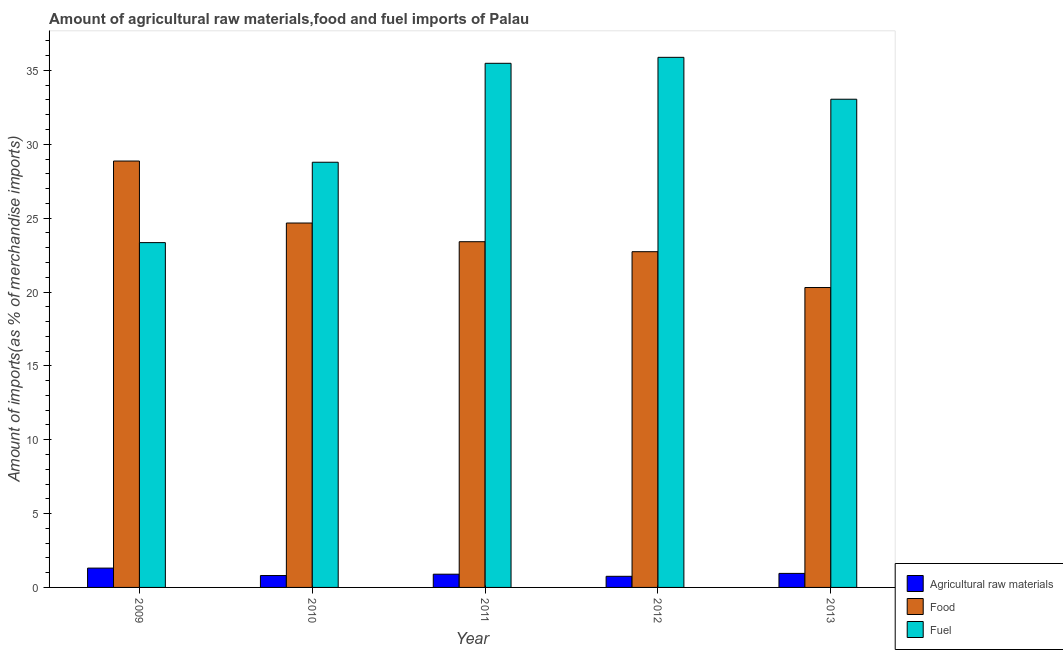Are the number of bars on each tick of the X-axis equal?
Ensure brevity in your answer.  Yes. What is the percentage of fuel imports in 2009?
Offer a very short reply. 23.34. Across all years, what is the maximum percentage of fuel imports?
Keep it short and to the point. 35.89. Across all years, what is the minimum percentage of food imports?
Ensure brevity in your answer.  20.3. What is the total percentage of fuel imports in the graph?
Your answer should be very brief. 156.55. What is the difference between the percentage of food imports in 2011 and that in 2012?
Provide a short and direct response. 0.68. What is the difference between the percentage of raw materials imports in 2010 and the percentage of fuel imports in 2011?
Ensure brevity in your answer.  -0.09. What is the average percentage of food imports per year?
Your response must be concise. 23.99. In the year 2010, what is the difference between the percentage of raw materials imports and percentage of fuel imports?
Provide a succinct answer. 0. What is the ratio of the percentage of raw materials imports in 2012 to that in 2013?
Make the answer very short. 0.79. Is the percentage of food imports in 2012 less than that in 2013?
Offer a terse response. No. Is the difference between the percentage of fuel imports in 2009 and 2010 greater than the difference between the percentage of food imports in 2009 and 2010?
Keep it short and to the point. No. What is the difference between the highest and the second highest percentage of raw materials imports?
Provide a succinct answer. 0.36. What is the difference between the highest and the lowest percentage of raw materials imports?
Your answer should be compact. 0.55. In how many years, is the percentage of food imports greater than the average percentage of food imports taken over all years?
Offer a terse response. 2. Is the sum of the percentage of raw materials imports in 2012 and 2013 greater than the maximum percentage of food imports across all years?
Ensure brevity in your answer.  Yes. What does the 3rd bar from the left in 2012 represents?
Make the answer very short. Fuel. What does the 3rd bar from the right in 2009 represents?
Keep it short and to the point. Agricultural raw materials. Is it the case that in every year, the sum of the percentage of raw materials imports and percentage of food imports is greater than the percentage of fuel imports?
Your response must be concise. No. How many bars are there?
Your response must be concise. 15. Are all the bars in the graph horizontal?
Your response must be concise. No. Does the graph contain any zero values?
Make the answer very short. No. Does the graph contain grids?
Give a very brief answer. No. Where does the legend appear in the graph?
Your response must be concise. Bottom right. What is the title of the graph?
Ensure brevity in your answer.  Amount of agricultural raw materials,food and fuel imports of Palau. What is the label or title of the Y-axis?
Your answer should be compact. Amount of imports(as % of merchandise imports). What is the Amount of imports(as % of merchandise imports) in Agricultural raw materials in 2009?
Your response must be concise. 1.31. What is the Amount of imports(as % of merchandise imports) of Food in 2009?
Ensure brevity in your answer.  28.87. What is the Amount of imports(as % of merchandise imports) of Fuel in 2009?
Provide a succinct answer. 23.34. What is the Amount of imports(as % of merchandise imports) of Agricultural raw materials in 2010?
Keep it short and to the point. 0.8. What is the Amount of imports(as % of merchandise imports) of Food in 2010?
Your response must be concise. 24.67. What is the Amount of imports(as % of merchandise imports) in Fuel in 2010?
Provide a succinct answer. 28.78. What is the Amount of imports(as % of merchandise imports) in Agricultural raw materials in 2011?
Offer a terse response. 0.9. What is the Amount of imports(as % of merchandise imports) in Food in 2011?
Your response must be concise. 23.4. What is the Amount of imports(as % of merchandise imports) of Fuel in 2011?
Make the answer very short. 35.48. What is the Amount of imports(as % of merchandise imports) of Agricultural raw materials in 2012?
Provide a succinct answer. 0.75. What is the Amount of imports(as % of merchandise imports) in Food in 2012?
Ensure brevity in your answer.  22.73. What is the Amount of imports(as % of merchandise imports) in Fuel in 2012?
Offer a terse response. 35.89. What is the Amount of imports(as % of merchandise imports) in Agricultural raw materials in 2013?
Provide a short and direct response. 0.95. What is the Amount of imports(as % of merchandise imports) of Food in 2013?
Keep it short and to the point. 20.3. What is the Amount of imports(as % of merchandise imports) in Fuel in 2013?
Keep it short and to the point. 33.05. Across all years, what is the maximum Amount of imports(as % of merchandise imports) of Agricultural raw materials?
Ensure brevity in your answer.  1.31. Across all years, what is the maximum Amount of imports(as % of merchandise imports) in Food?
Your response must be concise. 28.87. Across all years, what is the maximum Amount of imports(as % of merchandise imports) of Fuel?
Offer a very short reply. 35.89. Across all years, what is the minimum Amount of imports(as % of merchandise imports) in Agricultural raw materials?
Offer a terse response. 0.75. Across all years, what is the minimum Amount of imports(as % of merchandise imports) of Food?
Keep it short and to the point. 20.3. Across all years, what is the minimum Amount of imports(as % of merchandise imports) in Fuel?
Your answer should be compact. 23.34. What is the total Amount of imports(as % of merchandise imports) in Agricultural raw materials in the graph?
Provide a short and direct response. 4.71. What is the total Amount of imports(as % of merchandise imports) in Food in the graph?
Keep it short and to the point. 119.97. What is the total Amount of imports(as % of merchandise imports) in Fuel in the graph?
Make the answer very short. 156.55. What is the difference between the Amount of imports(as % of merchandise imports) of Agricultural raw materials in 2009 and that in 2010?
Provide a succinct answer. 0.5. What is the difference between the Amount of imports(as % of merchandise imports) in Food in 2009 and that in 2010?
Your answer should be compact. 4.2. What is the difference between the Amount of imports(as % of merchandise imports) of Fuel in 2009 and that in 2010?
Your answer should be compact. -5.44. What is the difference between the Amount of imports(as % of merchandise imports) of Agricultural raw materials in 2009 and that in 2011?
Your answer should be very brief. 0.41. What is the difference between the Amount of imports(as % of merchandise imports) of Food in 2009 and that in 2011?
Provide a short and direct response. 5.46. What is the difference between the Amount of imports(as % of merchandise imports) in Fuel in 2009 and that in 2011?
Make the answer very short. -12.14. What is the difference between the Amount of imports(as % of merchandise imports) in Agricultural raw materials in 2009 and that in 2012?
Your answer should be very brief. 0.56. What is the difference between the Amount of imports(as % of merchandise imports) of Food in 2009 and that in 2012?
Your answer should be very brief. 6.14. What is the difference between the Amount of imports(as % of merchandise imports) in Fuel in 2009 and that in 2012?
Offer a terse response. -12.54. What is the difference between the Amount of imports(as % of merchandise imports) in Agricultural raw materials in 2009 and that in 2013?
Your answer should be very brief. 0.36. What is the difference between the Amount of imports(as % of merchandise imports) of Food in 2009 and that in 2013?
Your answer should be very brief. 8.56. What is the difference between the Amount of imports(as % of merchandise imports) in Fuel in 2009 and that in 2013?
Give a very brief answer. -9.71. What is the difference between the Amount of imports(as % of merchandise imports) in Agricultural raw materials in 2010 and that in 2011?
Ensure brevity in your answer.  -0.09. What is the difference between the Amount of imports(as % of merchandise imports) in Food in 2010 and that in 2011?
Your response must be concise. 1.27. What is the difference between the Amount of imports(as % of merchandise imports) of Fuel in 2010 and that in 2011?
Keep it short and to the point. -6.7. What is the difference between the Amount of imports(as % of merchandise imports) of Agricultural raw materials in 2010 and that in 2012?
Keep it short and to the point. 0.05. What is the difference between the Amount of imports(as % of merchandise imports) of Food in 2010 and that in 2012?
Keep it short and to the point. 1.94. What is the difference between the Amount of imports(as % of merchandise imports) of Fuel in 2010 and that in 2012?
Offer a terse response. -7.1. What is the difference between the Amount of imports(as % of merchandise imports) of Agricultural raw materials in 2010 and that in 2013?
Give a very brief answer. -0.15. What is the difference between the Amount of imports(as % of merchandise imports) of Food in 2010 and that in 2013?
Offer a terse response. 4.37. What is the difference between the Amount of imports(as % of merchandise imports) of Fuel in 2010 and that in 2013?
Keep it short and to the point. -4.27. What is the difference between the Amount of imports(as % of merchandise imports) of Agricultural raw materials in 2011 and that in 2012?
Provide a succinct answer. 0.14. What is the difference between the Amount of imports(as % of merchandise imports) of Food in 2011 and that in 2012?
Offer a very short reply. 0.68. What is the difference between the Amount of imports(as % of merchandise imports) of Fuel in 2011 and that in 2012?
Keep it short and to the point. -0.4. What is the difference between the Amount of imports(as % of merchandise imports) in Agricultural raw materials in 2011 and that in 2013?
Ensure brevity in your answer.  -0.05. What is the difference between the Amount of imports(as % of merchandise imports) of Food in 2011 and that in 2013?
Your answer should be compact. 3.1. What is the difference between the Amount of imports(as % of merchandise imports) of Fuel in 2011 and that in 2013?
Give a very brief answer. 2.43. What is the difference between the Amount of imports(as % of merchandise imports) in Agricultural raw materials in 2012 and that in 2013?
Provide a short and direct response. -0.2. What is the difference between the Amount of imports(as % of merchandise imports) in Food in 2012 and that in 2013?
Offer a terse response. 2.43. What is the difference between the Amount of imports(as % of merchandise imports) of Fuel in 2012 and that in 2013?
Your answer should be compact. 2.84. What is the difference between the Amount of imports(as % of merchandise imports) in Agricultural raw materials in 2009 and the Amount of imports(as % of merchandise imports) in Food in 2010?
Your response must be concise. -23.36. What is the difference between the Amount of imports(as % of merchandise imports) in Agricultural raw materials in 2009 and the Amount of imports(as % of merchandise imports) in Fuel in 2010?
Offer a very short reply. -27.48. What is the difference between the Amount of imports(as % of merchandise imports) of Food in 2009 and the Amount of imports(as % of merchandise imports) of Fuel in 2010?
Provide a succinct answer. 0.08. What is the difference between the Amount of imports(as % of merchandise imports) of Agricultural raw materials in 2009 and the Amount of imports(as % of merchandise imports) of Food in 2011?
Provide a short and direct response. -22.1. What is the difference between the Amount of imports(as % of merchandise imports) of Agricultural raw materials in 2009 and the Amount of imports(as % of merchandise imports) of Fuel in 2011?
Ensure brevity in your answer.  -34.17. What is the difference between the Amount of imports(as % of merchandise imports) of Food in 2009 and the Amount of imports(as % of merchandise imports) of Fuel in 2011?
Ensure brevity in your answer.  -6.62. What is the difference between the Amount of imports(as % of merchandise imports) of Agricultural raw materials in 2009 and the Amount of imports(as % of merchandise imports) of Food in 2012?
Your answer should be compact. -21.42. What is the difference between the Amount of imports(as % of merchandise imports) of Agricultural raw materials in 2009 and the Amount of imports(as % of merchandise imports) of Fuel in 2012?
Your answer should be very brief. -34.58. What is the difference between the Amount of imports(as % of merchandise imports) of Food in 2009 and the Amount of imports(as % of merchandise imports) of Fuel in 2012?
Offer a terse response. -7.02. What is the difference between the Amount of imports(as % of merchandise imports) of Agricultural raw materials in 2009 and the Amount of imports(as % of merchandise imports) of Food in 2013?
Offer a terse response. -18.99. What is the difference between the Amount of imports(as % of merchandise imports) in Agricultural raw materials in 2009 and the Amount of imports(as % of merchandise imports) in Fuel in 2013?
Give a very brief answer. -31.74. What is the difference between the Amount of imports(as % of merchandise imports) in Food in 2009 and the Amount of imports(as % of merchandise imports) in Fuel in 2013?
Ensure brevity in your answer.  -4.18. What is the difference between the Amount of imports(as % of merchandise imports) in Agricultural raw materials in 2010 and the Amount of imports(as % of merchandise imports) in Food in 2011?
Give a very brief answer. -22.6. What is the difference between the Amount of imports(as % of merchandise imports) of Agricultural raw materials in 2010 and the Amount of imports(as % of merchandise imports) of Fuel in 2011?
Your response must be concise. -34.68. What is the difference between the Amount of imports(as % of merchandise imports) of Food in 2010 and the Amount of imports(as % of merchandise imports) of Fuel in 2011?
Offer a terse response. -10.81. What is the difference between the Amount of imports(as % of merchandise imports) in Agricultural raw materials in 2010 and the Amount of imports(as % of merchandise imports) in Food in 2012?
Your response must be concise. -21.92. What is the difference between the Amount of imports(as % of merchandise imports) in Agricultural raw materials in 2010 and the Amount of imports(as % of merchandise imports) in Fuel in 2012?
Provide a short and direct response. -35.08. What is the difference between the Amount of imports(as % of merchandise imports) of Food in 2010 and the Amount of imports(as % of merchandise imports) of Fuel in 2012?
Make the answer very short. -11.22. What is the difference between the Amount of imports(as % of merchandise imports) in Agricultural raw materials in 2010 and the Amount of imports(as % of merchandise imports) in Food in 2013?
Ensure brevity in your answer.  -19.5. What is the difference between the Amount of imports(as % of merchandise imports) of Agricultural raw materials in 2010 and the Amount of imports(as % of merchandise imports) of Fuel in 2013?
Offer a terse response. -32.25. What is the difference between the Amount of imports(as % of merchandise imports) of Food in 2010 and the Amount of imports(as % of merchandise imports) of Fuel in 2013?
Your answer should be very brief. -8.38. What is the difference between the Amount of imports(as % of merchandise imports) of Agricultural raw materials in 2011 and the Amount of imports(as % of merchandise imports) of Food in 2012?
Provide a short and direct response. -21.83. What is the difference between the Amount of imports(as % of merchandise imports) of Agricultural raw materials in 2011 and the Amount of imports(as % of merchandise imports) of Fuel in 2012?
Give a very brief answer. -34.99. What is the difference between the Amount of imports(as % of merchandise imports) of Food in 2011 and the Amount of imports(as % of merchandise imports) of Fuel in 2012?
Ensure brevity in your answer.  -12.48. What is the difference between the Amount of imports(as % of merchandise imports) in Agricultural raw materials in 2011 and the Amount of imports(as % of merchandise imports) in Food in 2013?
Your answer should be compact. -19.41. What is the difference between the Amount of imports(as % of merchandise imports) of Agricultural raw materials in 2011 and the Amount of imports(as % of merchandise imports) of Fuel in 2013?
Your answer should be compact. -32.15. What is the difference between the Amount of imports(as % of merchandise imports) in Food in 2011 and the Amount of imports(as % of merchandise imports) in Fuel in 2013?
Offer a very short reply. -9.65. What is the difference between the Amount of imports(as % of merchandise imports) of Agricultural raw materials in 2012 and the Amount of imports(as % of merchandise imports) of Food in 2013?
Make the answer very short. -19.55. What is the difference between the Amount of imports(as % of merchandise imports) in Agricultural raw materials in 2012 and the Amount of imports(as % of merchandise imports) in Fuel in 2013?
Your response must be concise. -32.3. What is the difference between the Amount of imports(as % of merchandise imports) in Food in 2012 and the Amount of imports(as % of merchandise imports) in Fuel in 2013?
Provide a short and direct response. -10.32. What is the average Amount of imports(as % of merchandise imports) in Agricultural raw materials per year?
Offer a terse response. 0.94. What is the average Amount of imports(as % of merchandise imports) of Food per year?
Offer a terse response. 23.99. What is the average Amount of imports(as % of merchandise imports) in Fuel per year?
Keep it short and to the point. 31.31. In the year 2009, what is the difference between the Amount of imports(as % of merchandise imports) of Agricultural raw materials and Amount of imports(as % of merchandise imports) of Food?
Keep it short and to the point. -27.56. In the year 2009, what is the difference between the Amount of imports(as % of merchandise imports) in Agricultural raw materials and Amount of imports(as % of merchandise imports) in Fuel?
Your response must be concise. -22.03. In the year 2009, what is the difference between the Amount of imports(as % of merchandise imports) in Food and Amount of imports(as % of merchandise imports) in Fuel?
Your answer should be compact. 5.52. In the year 2010, what is the difference between the Amount of imports(as % of merchandise imports) in Agricultural raw materials and Amount of imports(as % of merchandise imports) in Food?
Give a very brief answer. -23.87. In the year 2010, what is the difference between the Amount of imports(as % of merchandise imports) in Agricultural raw materials and Amount of imports(as % of merchandise imports) in Fuel?
Provide a succinct answer. -27.98. In the year 2010, what is the difference between the Amount of imports(as % of merchandise imports) in Food and Amount of imports(as % of merchandise imports) in Fuel?
Provide a succinct answer. -4.11. In the year 2011, what is the difference between the Amount of imports(as % of merchandise imports) of Agricultural raw materials and Amount of imports(as % of merchandise imports) of Food?
Your answer should be very brief. -22.51. In the year 2011, what is the difference between the Amount of imports(as % of merchandise imports) in Agricultural raw materials and Amount of imports(as % of merchandise imports) in Fuel?
Provide a succinct answer. -34.59. In the year 2011, what is the difference between the Amount of imports(as % of merchandise imports) of Food and Amount of imports(as % of merchandise imports) of Fuel?
Give a very brief answer. -12.08. In the year 2012, what is the difference between the Amount of imports(as % of merchandise imports) in Agricultural raw materials and Amount of imports(as % of merchandise imports) in Food?
Offer a very short reply. -21.98. In the year 2012, what is the difference between the Amount of imports(as % of merchandise imports) of Agricultural raw materials and Amount of imports(as % of merchandise imports) of Fuel?
Your answer should be compact. -35.13. In the year 2012, what is the difference between the Amount of imports(as % of merchandise imports) in Food and Amount of imports(as % of merchandise imports) in Fuel?
Ensure brevity in your answer.  -13.16. In the year 2013, what is the difference between the Amount of imports(as % of merchandise imports) of Agricultural raw materials and Amount of imports(as % of merchandise imports) of Food?
Ensure brevity in your answer.  -19.35. In the year 2013, what is the difference between the Amount of imports(as % of merchandise imports) in Agricultural raw materials and Amount of imports(as % of merchandise imports) in Fuel?
Make the answer very short. -32.1. In the year 2013, what is the difference between the Amount of imports(as % of merchandise imports) of Food and Amount of imports(as % of merchandise imports) of Fuel?
Provide a succinct answer. -12.75. What is the ratio of the Amount of imports(as % of merchandise imports) in Agricultural raw materials in 2009 to that in 2010?
Keep it short and to the point. 1.63. What is the ratio of the Amount of imports(as % of merchandise imports) in Food in 2009 to that in 2010?
Give a very brief answer. 1.17. What is the ratio of the Amount of imports(as % of merchandise imports) of Fuel in 2009 to that in 2010?
Your answer should be very brief. 0.81. What is the ratio of the Amount of imports(as % of merchandise imports) in Agricultural raw materials in 2009 to that in 2011?
Your response must be concise. 1.46. What is the ratio of the Amount of imports(as % of merchandise imports) in Food in 2009 to that in 2011?
Offer a very short reply. 1.23. What is the ratio of the Amount of imports(as % of merchandise imports) in Fuel in 2009 to that in 2011?
Provide a succinct answer. 0.66. What is the ratio of the Amount of imports(as % of merchandise imports) in Agricultural raw materials in 2009 to that in 2012?
Provide a succinct answer. 1.74. What is the ratio of the Amount of imports(as % of merchandise imports) in Food in 2009 to that in 2012?
Your response must be concise. 1.27. What is the ratio of the Amount of imports(as % of merchandise imports) in Fuel in 2009 to that in 2012?
Your answer should be very brief. 0.65. What is the ratio of the Amount of imports(as % of merchandise imports) in Agricultural raw materials in 2009 to that in 2013?
Make the answer very short. 1.38. What is the ratio of the Amount of imports(as % of merchandise imports) of Food in 2009 to that in 2013?
Provide a succinct answer. 1.42. What is the ratio of the Amount of imports(as % of merchandise imports) of Fuel in 2009 to that in 2013?
Your response must be concise. 0.71. What is the ratio of the Amount of imports(as % of merchandise imports) in Agricultural raw materials in 2010 to that in 2011?
Make the answer very short. 0.9. What is the ratio of the Amount of imports(as % of merchandise imports) of Food in 2010 to that in 2011?
Keep it short and to the point. 1.05. What is the ratio of the Amount of imports(as % of merchandise imports) of Fuel in 2010 to that in 2011?
Ensure brevity in your answer.  0.81. What is the ratio of the Amount of imports(as % of merchandise imports) in Agricultural raw materials in 2010 to that in 2012?
Keep it short and to the point. 1.07. What is the ratio of the Amount of imports(as % of merchandise imports) in Food in 2010 to that in 2012?
Offer a very short reply. 1.09. What is the ratio of the Amount of imports(as % of merchandise imports) of Fuel in 2010 to that in 2012?
Offer a terse response. 0.8. What is the ratio of the Amount of imports(as % of merchandise imports) in Agricultural raw materials in 2010 to that in 2013?
Your answer should be very brief. 0.85. What is the ratio of the Amount of imports(as % of merchandise imports) of Food in 2010 to that in 2013?
Offer a terse response. 1.22. What is the ratio of the Amount of imports(as % of merchandise imports) of Fuel in 2010 to that in 2013?
Keep it short and to the point. 0.87. What is the ratio of the Amount of imports(as % of merchandise imports) of Agricultural raw materials in 2011 to that in 2012?
Provide a short and direct response. 1.19. What is the ratio of the Amount of imports(as % of merchandise imports) in Food in 2011 to that in 2012?
Keep it short and to the point. 1.03. What is the ratio of the Amount of imports(as % of merchandise imports) of Fuel in 2011 to that in 2012?
Your answer should be compact. 0.99. What is the ratio of the Amount of imports(as % of merchandise imports) in Agricultural raw materials in 2011 to that in 2013?
Offer a very short reply. 0.94. What is the ratio of the Amount of imports(as % of merchandise imports) in Food in 2011 to that in 2013?
Your answer should be compact. 1.15. What is the ratio of the Amount of imports(as % of merchandise imports) of Fuel in 2011 to that in 2013?
Offer a terse response. 1.07. What is the ratio of the Amount of imports(as % of merchandise imports) in Agricultural raw materials in 2012 to that in 2013?
Offer a terse response. 0.79. What is the ratio of the Amount of imports(as % of merchandise imports) of Food in 2012 to that in 2013?
Ensure brevity in your answer.  1.12. What is the ratio of the Amount of imports(as % of merchandise imports) of Fuel in 2012 to that in 2013?
Make the answer very short. 1.09. What is the difference between the highest and the second highest Amount of imports(as % of merchandise imports) of Agricultural raw materials?
Your answer should be very brief. 0.36. What is the difference between the highest and the second highest Amount of imports(as % of merchandise imports) of Food?
Your answer should be very brief. 4.2. What is the difference between the highest and the second highest Amount of imports(as % of merchandise imports) in Fuel?
Your answer should be compact. 0.4. What is the difference between the highest and the lowest Amount of imports(as % of merchandise imports) of Agricultural raw materials?
Make the answer very short. 0.56. What is the difference between the highest and the lowest Amount of imports(as % of merchandise imports) in Food?
Provide a succinct answer. 8.56. What is the difference between the highest and the lowest Amount of imports(as % of merchandise imports) in Fuel?
Your answer should be compact. 12.54. 